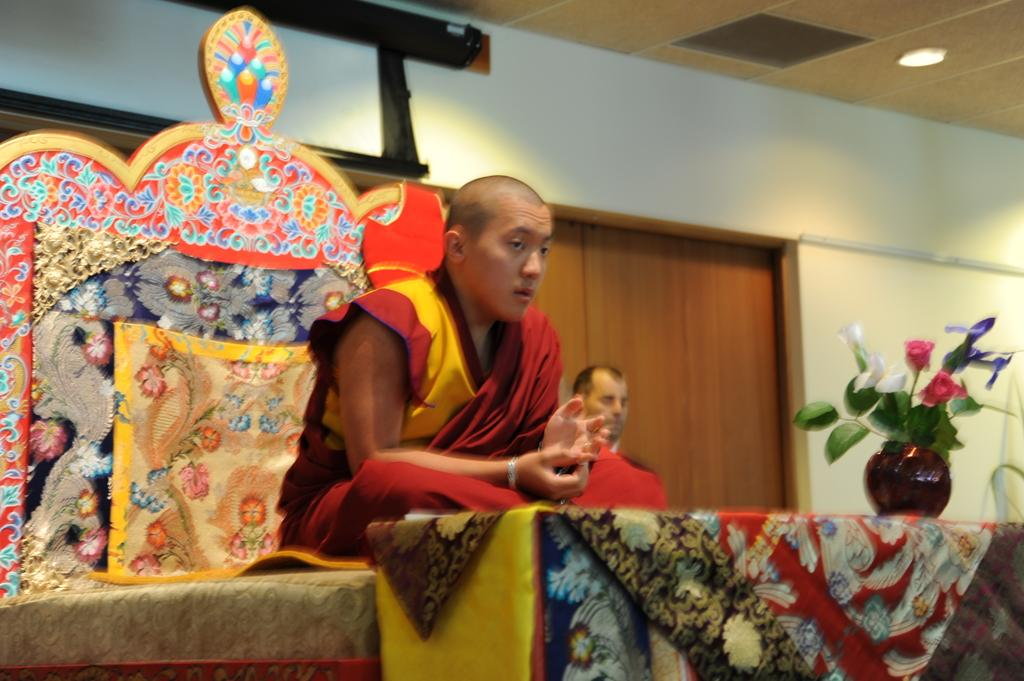Who is present in the image? There is a man in the image. What is the man wearing? The man is wearing a red dress. What is the man's position in the image? The man is sitting on a sofa. What is in front of the man? There is a table in front of the man. What is on the table? There is a plant on the table. What can be seen in the background of the image? There is a door and a wall in the background of the image. How many owls are sitting on the man's shoulder in the image? There are no owls present in the image. What are the girls doing in the image? There are no girls present in the image. 